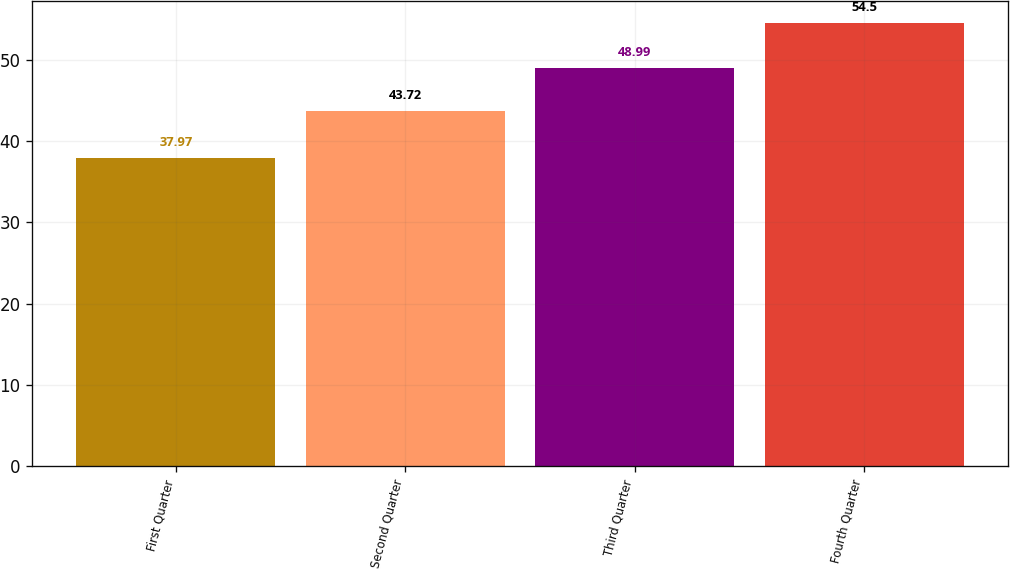<chart> <loc_0><loc_0><loc_500><loc_500><bar_chart><fcel>First Quarter<fcel>Second Quarter<fcel>Third Quarter<fcel>Fourth Quarter<nl><fcel>37.97<fcel>43.72<fcel>48.99<fcel>54.5<nl></chart> 